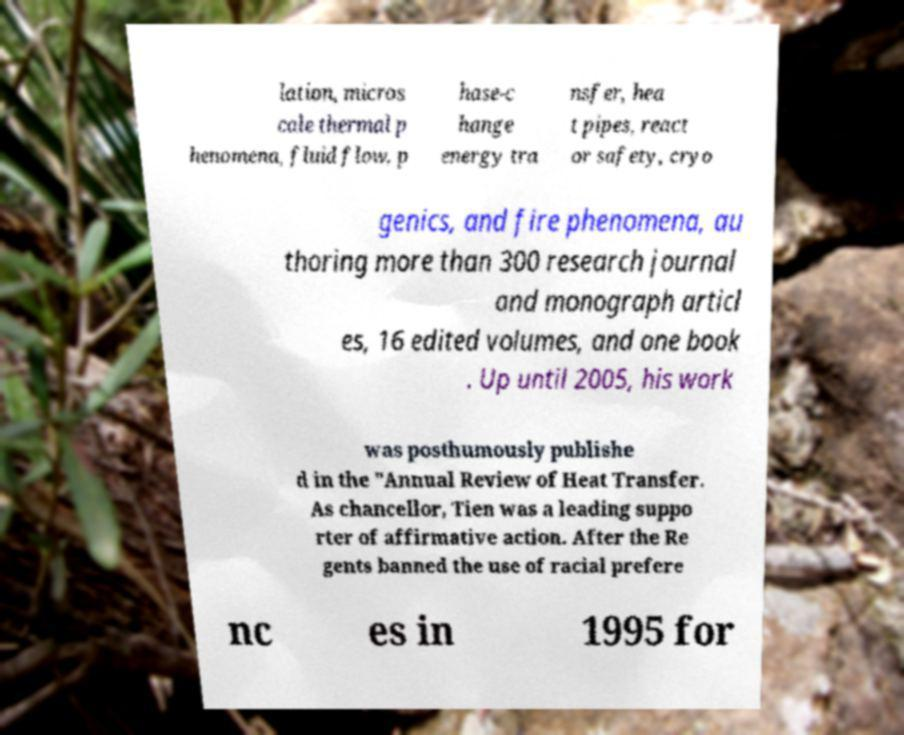Can you accurately transcribe the text from the provided image for me? lation, micros cale thermal p henomena, fluid flow, p hase-c hange energy tra nsfer, hea t pipes, react or safety, cryo genics, and fire phenomena, au thoring more than 300 research journal and monograph articl es, 16 edited volumes, and one book . Up until 2005, his work was posthumously publishe d in the "Annual Review of Heat Transfer. As chancellor, Tien was a leading suppo rter of affirmative action. After the Re gents banned the use of racial prefere nc es in 1995 for 